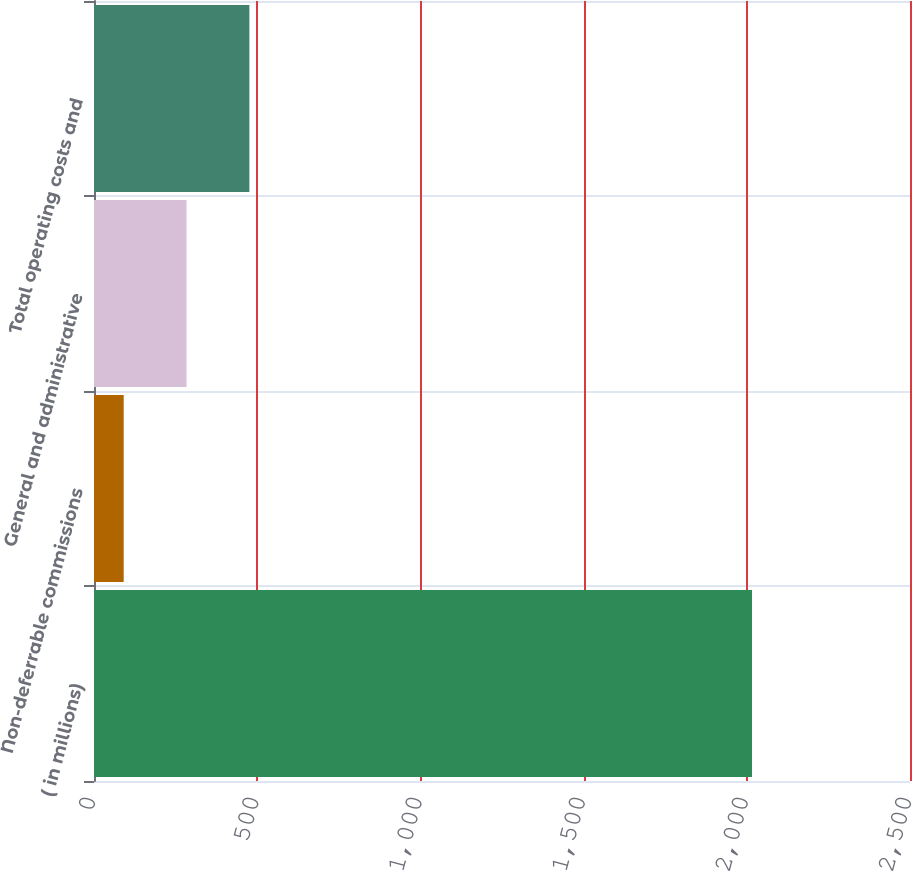Convert chart to OTSL. <chart><loc_0><loc_0><loc_500><loc_500><bar_chart><fcel>( in millions)<fcel>Non-deferrable commissions<fcel>General and administrative<fcel>Total operating costs and<nl><fcel>2016<fcel>91<fcel>283.5<fcel>476<nl></chart> 